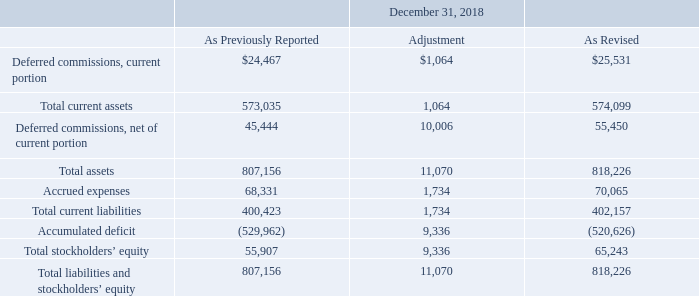Revision of Prior Period Financial Statements
During the preparation of the financial statements for the three months ended September 30, 2019, the Company identified a misstatement in previously issued financial statements. The misstatement related to an error in the measurement of the cumulative effect of the accounting change related to the Company’s January 1, 2018 adoption of Accounting Standards Update No. 2014-09, “Revenue from Contracts with Customers (Topic 606)” (“ASU 2014-09” or “Topic 606”) and impacted the January 1, 2018 opening accumulated deficit balance and the related opening balances of deferred commissions assets and accrued expenses. The Company determined that the error was not material to any previously issued financial statements. The Company has revised the December 31, 2018 consolidated balance sheet and the statements of changes in stockholders’ equity for all periods after January 1, 2018 to correct the misstatement as follows (in thousands):
Which date's opening accumulated deficit balance did the company's misstatement affect? January 1, 2018. What was the total current assets as previously reported?
Answer scale should be: thousand. 573,035. What were the total assets as revised?
Answer scale should be: thousand. 818,226. What was the total adjustment of total current assets and total assets?
Answer scale should be: thousand. 1,064+11,070
Answer: 12134. What was the sum of deferred commissions, current portion and total current assets as previously reported?
Answer scale should be: thousand. $24,467+573,035
Answer: 597502. What was accrued expenses as revised as a percentage of total liabilities and stockholders' equity?
Answer scale should be: percent. (70,065/818,226)
Answer: 8.56. 